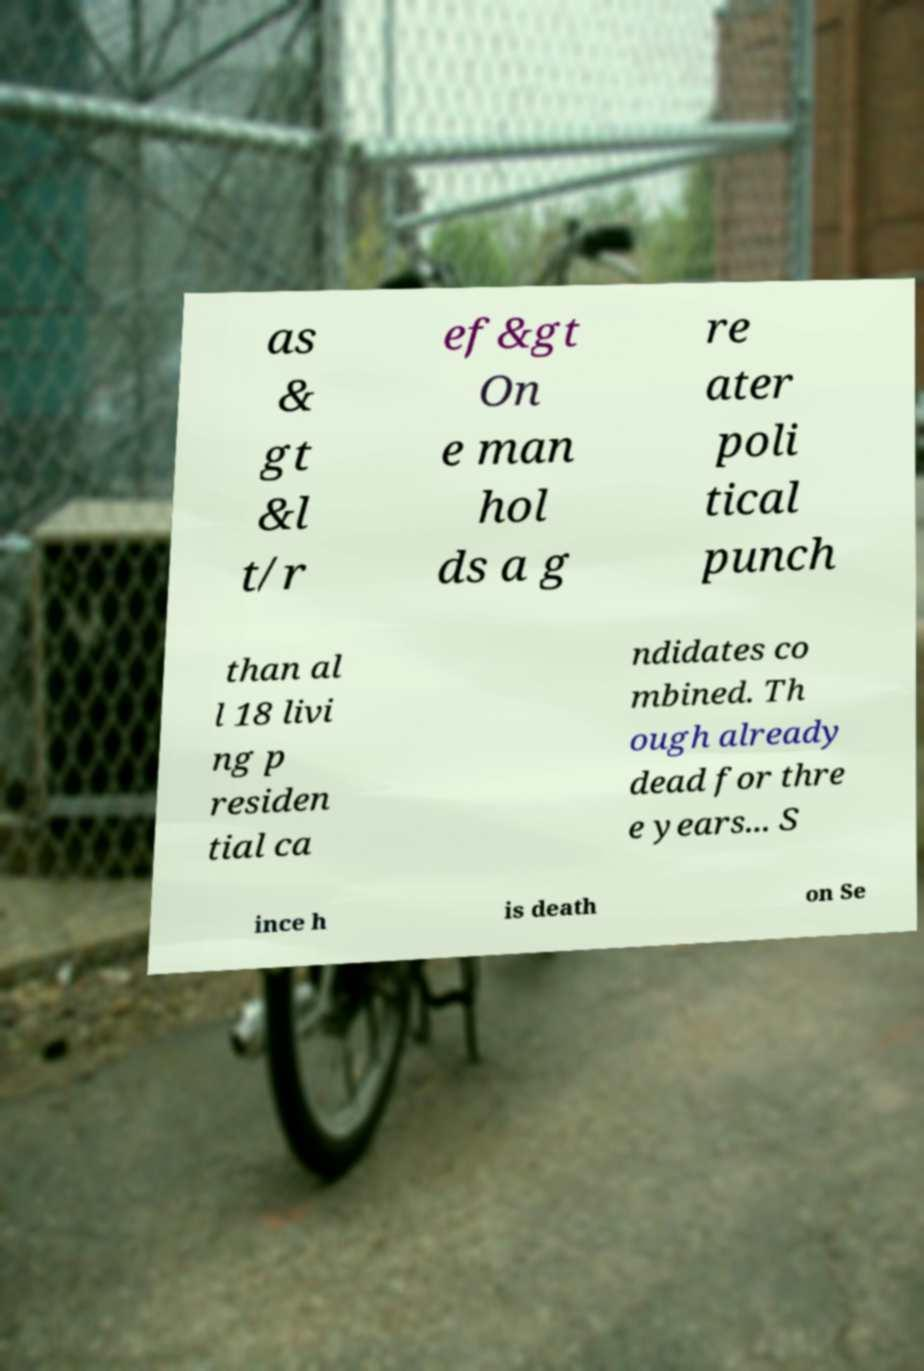Please identify and transcribe the text found in this image. as & gt &l t/r ef&gt On e man hol ds a g re ater poli tical punch than al l 18 livi ng p residen tial ca ndidates co mbined. Th ough already dead for thre e years... S ince h is death on Se 